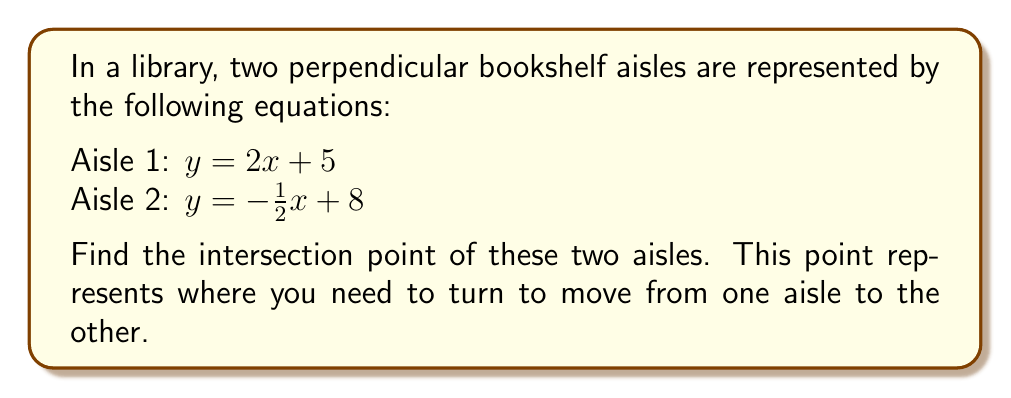Teach me how to tackle this problem. Let's approach this step-by-step:

1) We know that the two lines are perpendicular. We can verify this by checking if the product of their slopes is -1:
   
   Slope of Aisle 1: $m_1 = 2$
   Slope of Aisle 2: $m_2 = -\frac{1}{2}$
   
   $m_1 \cdot m_2 = 2 \cdot (-\frac{1}{2}) = -1$

   This confirms that the lines are indeed perpendicular.

2) To find the intersection point, we need to solve the system of equations:

   $$\begin{cases}
   y = 2x + 5 \\
   y = -\frac{1}{2}x + 8
   \end{cases}$$

3) Since both equations are equal to y, we can set them equal to each other:

   $$2x + 5 = -\frac{1}{2}x + 8$$

4) Now, let's solve for x:
   
   $$2x + \frac{1}{2}x = 8 - 5$$
   $$\frac{5}{2}x = 3$$
   $$x = \frac{3}{\frac{5}{2}} = \frac{6}{5} = 1.2$$

5) Now that we know x, we can substitute it into either of the original equations to find y. Let's use the first equation:

   $$y = 2(1.2) + 5 = 2.4 + 5 = 7.4$$

6) Therefore, the intersection point is (1.2, 7.4).

[asy]
import geometry;

size(200);
real xmin = -1, xmax = 5, ymin = 0, ymax = 10;
real xscale = 100 / (xmax - xmin), yscale = 100 / (ymax - ymin);

void drawAxes() {
  draw((xmin,0)--(xmax,0), arrow=Arrow(TeXHead));
  draw((0,ymin)--(0,ymax), arrow=Arrow(TeXHead));
  for (int i = ceil(xmin); i <= floor(xmax); ++i) {
    draw((i, -0.1)--(i, 0.1));
    label(format("%d", i), (i, -0.3), S);
  }
  for (int i = ceil(ymin); i <= floor(ymax); ++i) {
    draw((-0.1, i)--(0.1, i));
    label(format("%d", i), (-0.3, i), W);
  }
}

drawAxes();

path aisle1 = graph(function(real x) { return 2x + 5; }, xmin, xmax);
path aisle2 = graph(function(real x) { return -0.5x + 8; }, xmin, xmax);

draw(aisle1, red+1pt, legend="Aisle 1");
draw(aisle2, blue+1pt, legend="Aisle 2");

dot((1.2, 7.4), green+4pt);
label("(1.2, 7.4)", (1.2, 7.4), NE);

legend();
[/asy]
Answer: The intersection point of the two perpendicular bookshelf aisles is (1.2, 7.4). 